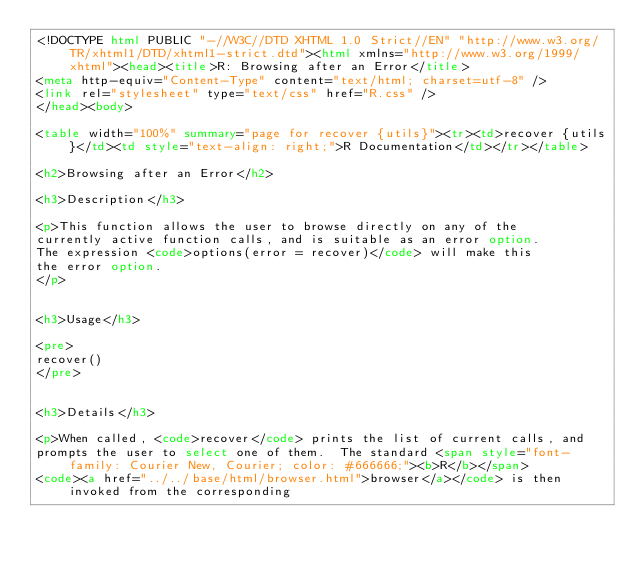Convert code to text. <code><loc_0><loc_0><loc_500><loc_500><_HTML_><!DOCTYPE html PUBLIC "-//W3C//DTD XHTML 1.0 Strict//EN" "http://www.w3.org/TR/xhtml1/DTD/xhtml1-strict.dtd"><html xmlns="http://www.w3.org/1999/xhtml"><head><title>R: Browsing after an Error</title>
<meta http-equiv="Content-Type" content="text/html; charset=utf-8" />
<link rel="stylesheet" type="text/css" href="R.css" />
</head><body>

<table width="100%" summary="page for recover {utils}"><tr><td>recover {utils}</td><td style="text-align: right;">R Documentation</td></tr></table>

<h2>Browsing after an Error</h2>

<h3>Description</h3>

<p>This function allows the user to browse directly on any of the
currently active function calls, and is suitable as an error option.
The expression <code>options(error = recover)</code> will make this
the error option.
</p>


<h3>Usage</h3>

<pre>
recover()
</pre>


<h3>Details</h3>

<p>When called, <code>recover</code> prints the list of current calls, and
prompts the user to select one of them.  The standard <span style="font-family: Courier New, Courier; color: #666666;"><b>R</b></span>
<code><a href="../../base/html/browser.html">browser</a></code> is then invoked from the corresponding</code> 